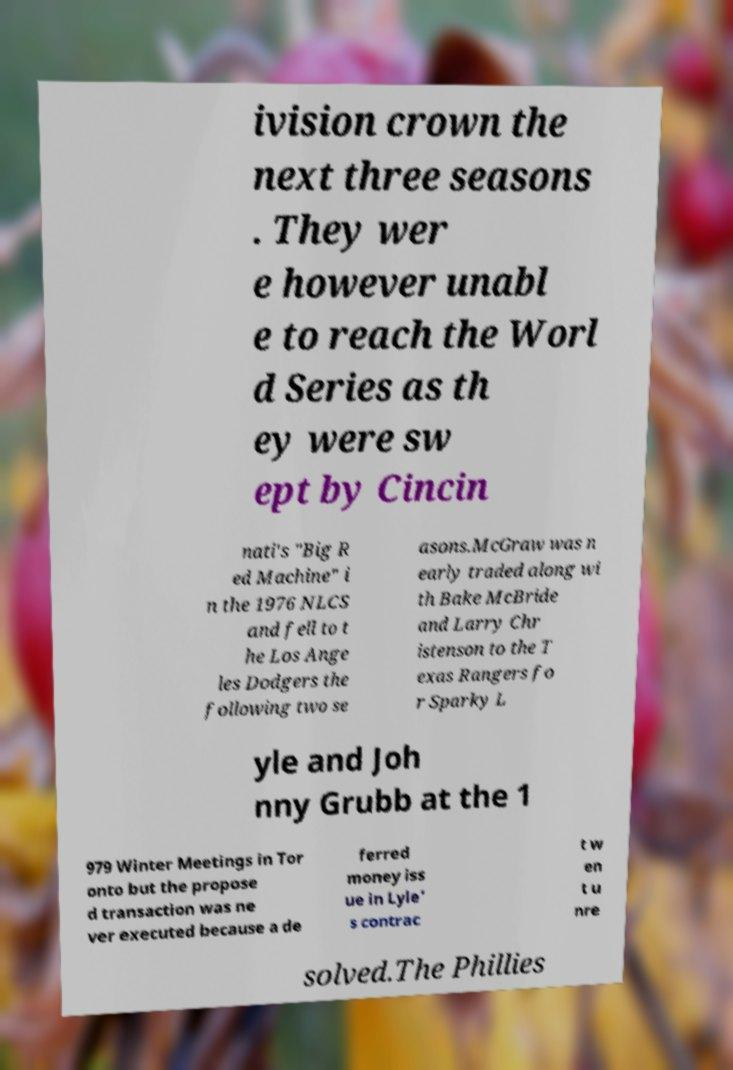Can you read and provide the text displayed in the image?This photo seems to have some interesting text. Can you extract and type it out for me? ivision crown the next three seasons . They wer e however unabl e to reach the Worl d Series as th ey were sw ept by Cincin nati's "Big R ed Machine" i n the 1976 NLCS and fell to t he Los Ange les Dodgers the following two se asons.McGraw was n early traded along wi th Bake McBride and Larry Chr istenson to the T exas Rangers fo r Sparky L yle and Joh nny Grubb at the 1 979 Winter Meetings in Tor onto but the propose d transaction was ne ver executed because a de ferred money iss ue in Lyle' s contrac t w en t u nre solved.The Phillies 